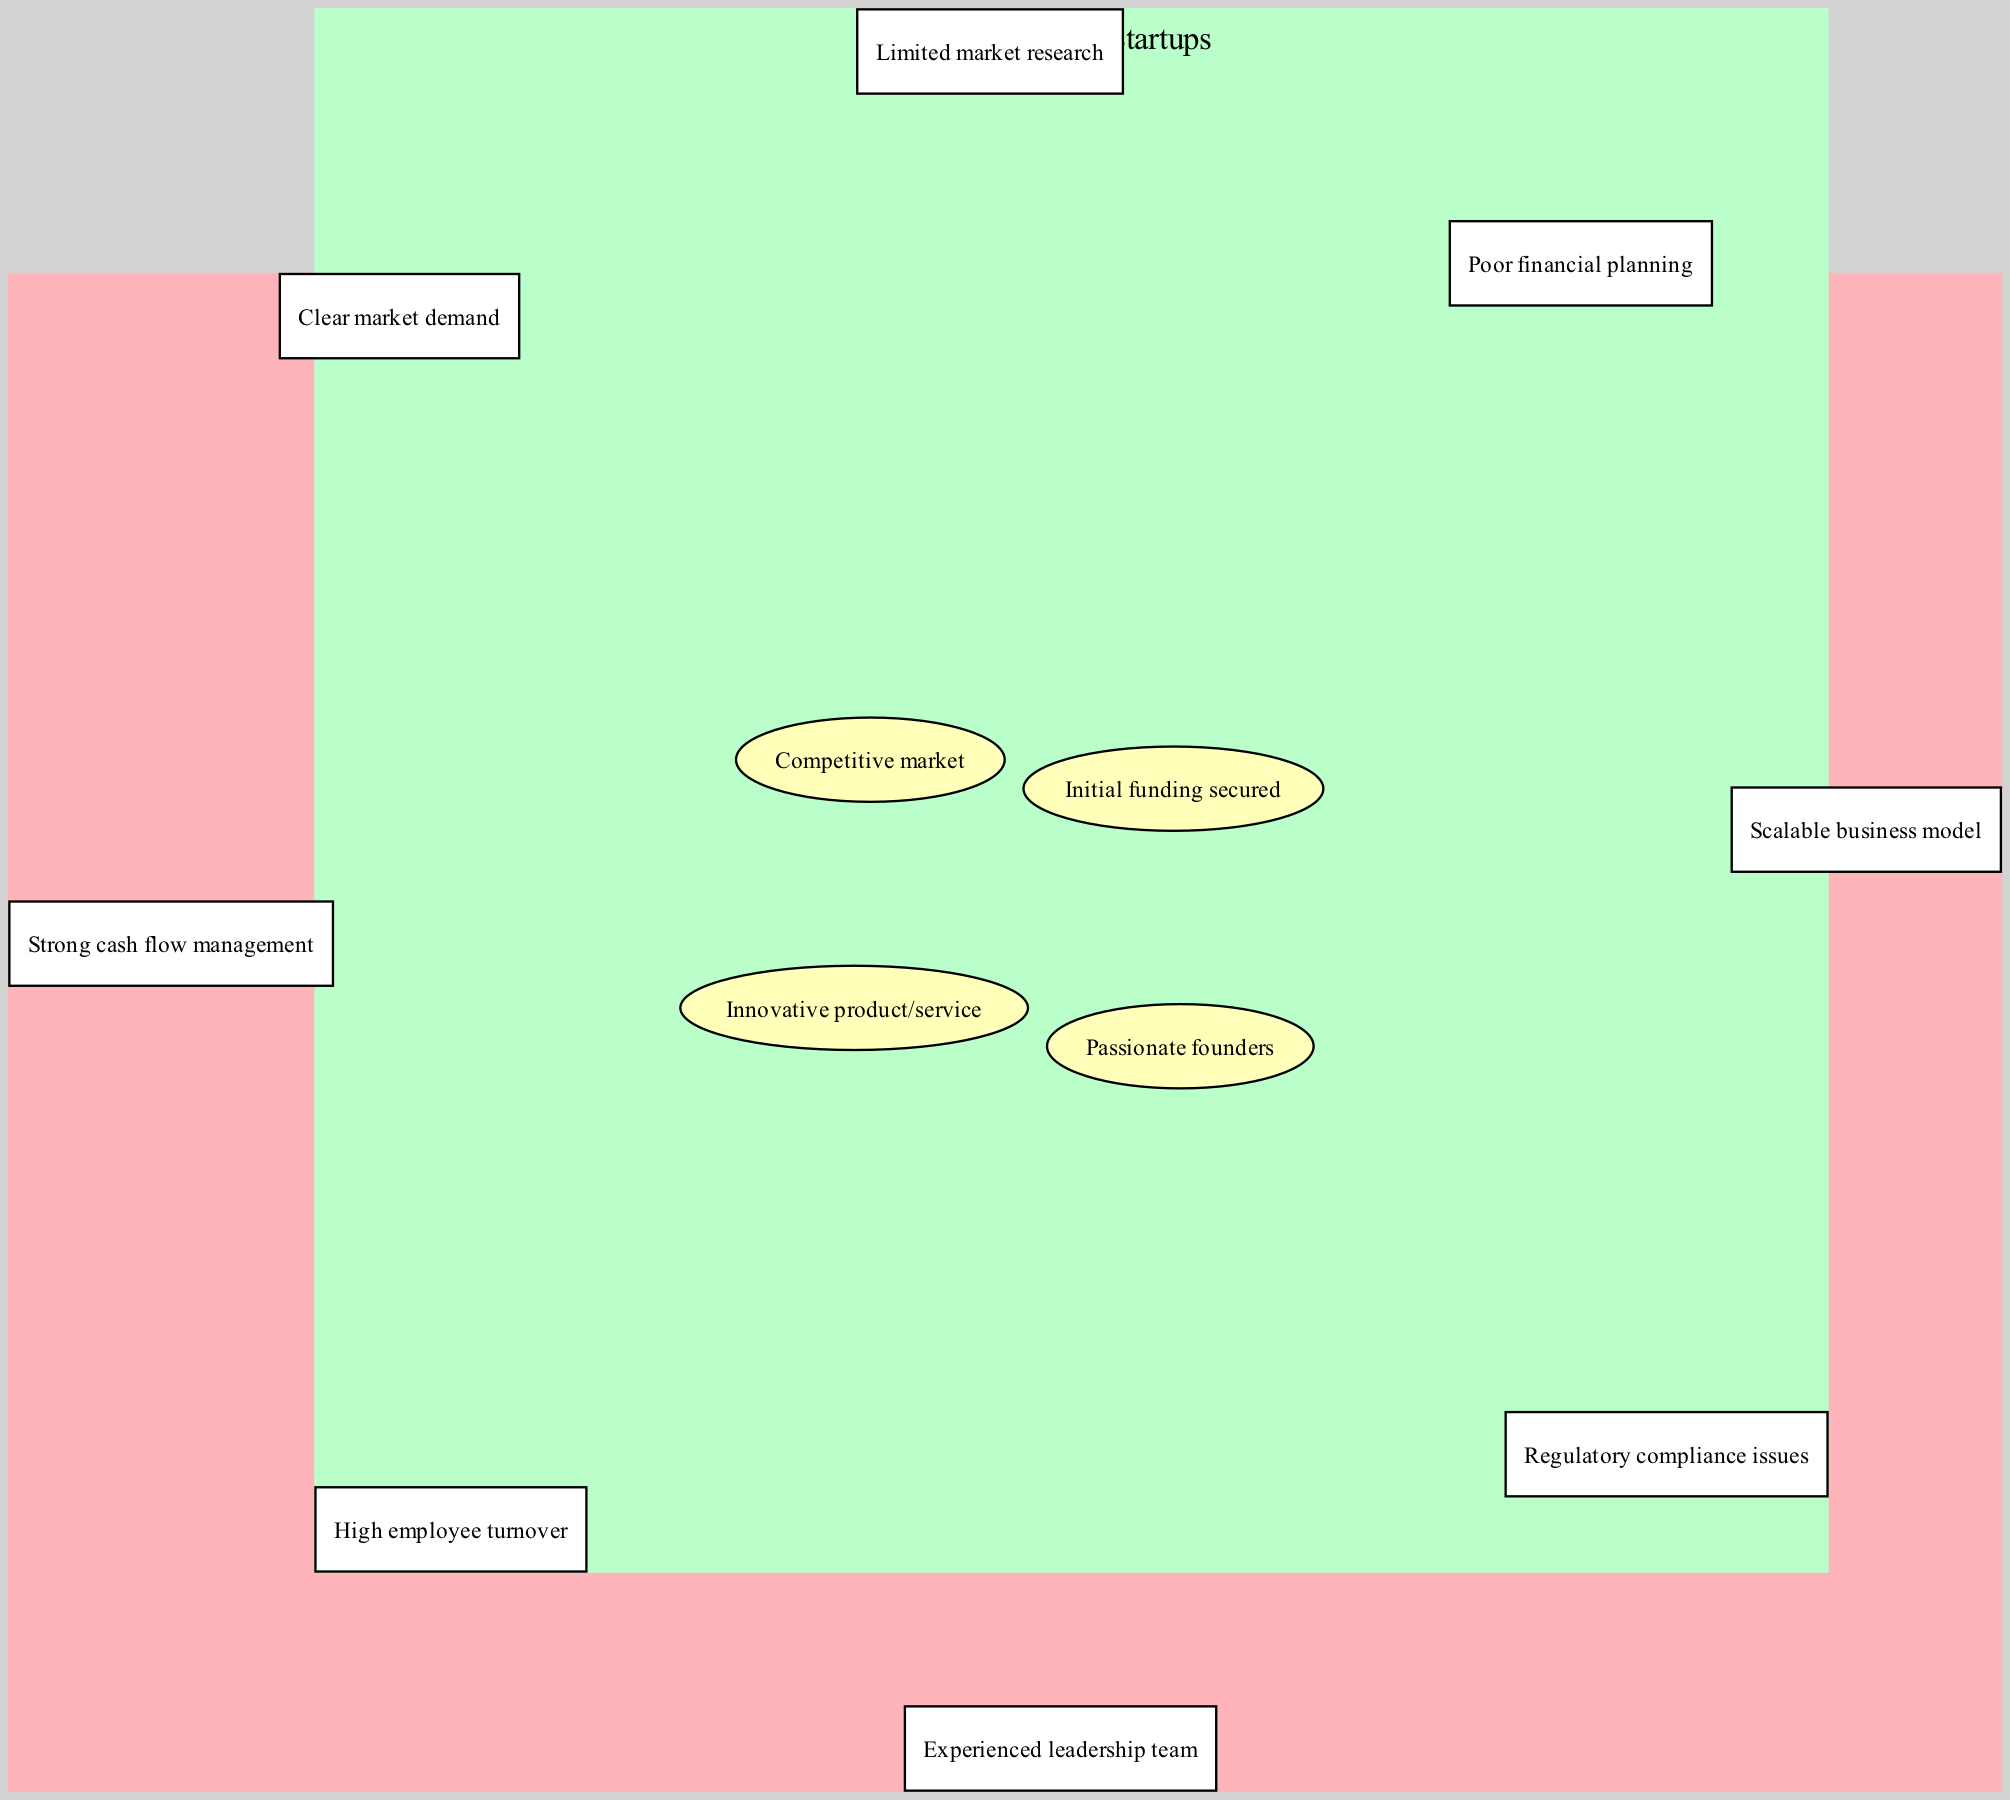What are the elements of Successful Startups? The diagram lists the elements of Successful Startups on the left side. These are "Strong cash flow management," "Scalable business model," "Experienced leadership team," and "Clear market demand."
Answer: Strong cash flow management, Scalable business model, Experienced leadership team, Clear market demand What are the elements of Unsuccessful Startups? The diagram shows the elements of Unsuccessful Startups on the right side. They include "Poor financial planning," "Limited market research," "High employee turnover," and "Regulatory compliance issues."
Answer: Poor financial planning, Limited market research, High employee turnover, Regulatory compliance issues How many elements are in the intersection? The intersection, located in the center of the diagram, lists four elements: "Innovative product/service," "Passionate founders," "Initial funding secured," and "Competitive market." Therefore, there are four elements.
Answer: 4 What is one characteristic common to both Successful and Unsuccessful Startups? The intersection of the diagram indicates common characteristics shared by both sets. For example, "Innovative product/service" appears in the center, showing it is a shared characteristic.
Answer: Innovative product/service Identify one factor that is unique to Successful Startups. Looking at the left side of the diagram, the element "Strong cash flow management" is presented as an exclusive factor that characterizes Successful Startups, showing its importance in their success.
Answer: Strong cash flow management What is the primary difference in characteristics between the two types of Startups? The diagram visually separates successful and unsuccessful characteristics. While Successful Startups have traits that contribute positively to their outcome, such as "Clear market demand," Unsuccessful Startups exhibit negative traits like "Poor financial planning."
Answer: Positive vs Negative traits How many total elements are represented in the diagram? To find the total elements, we add the elements from both sets and the intersection. There are 4 from Successful Startups, 4 from Unsuccessful Startups, and 4 in the intersection. Thus, the total is 12 elements.
Answer: 12 Which startup has the characteristic of "High employee turnover"? This characteristic is found on the right side of the diagram, specifically under Unsuccessful Startups, indicating that it is a trait associated with their failure.
Answer: Unsuccessful Startups What does the overlap signify in the context of Startups? The overlap in the center of the diagram indicates shared characteristics that can be seen in both Successful and Unsuccessful Startups, suggesting that even those that fail may possess similar elements found in successful ventures.
Answer: Shared characteristics 